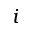Convert formula to latex. <formula><loc_0><loc_0><loc_500><loc_500>i</formula> 